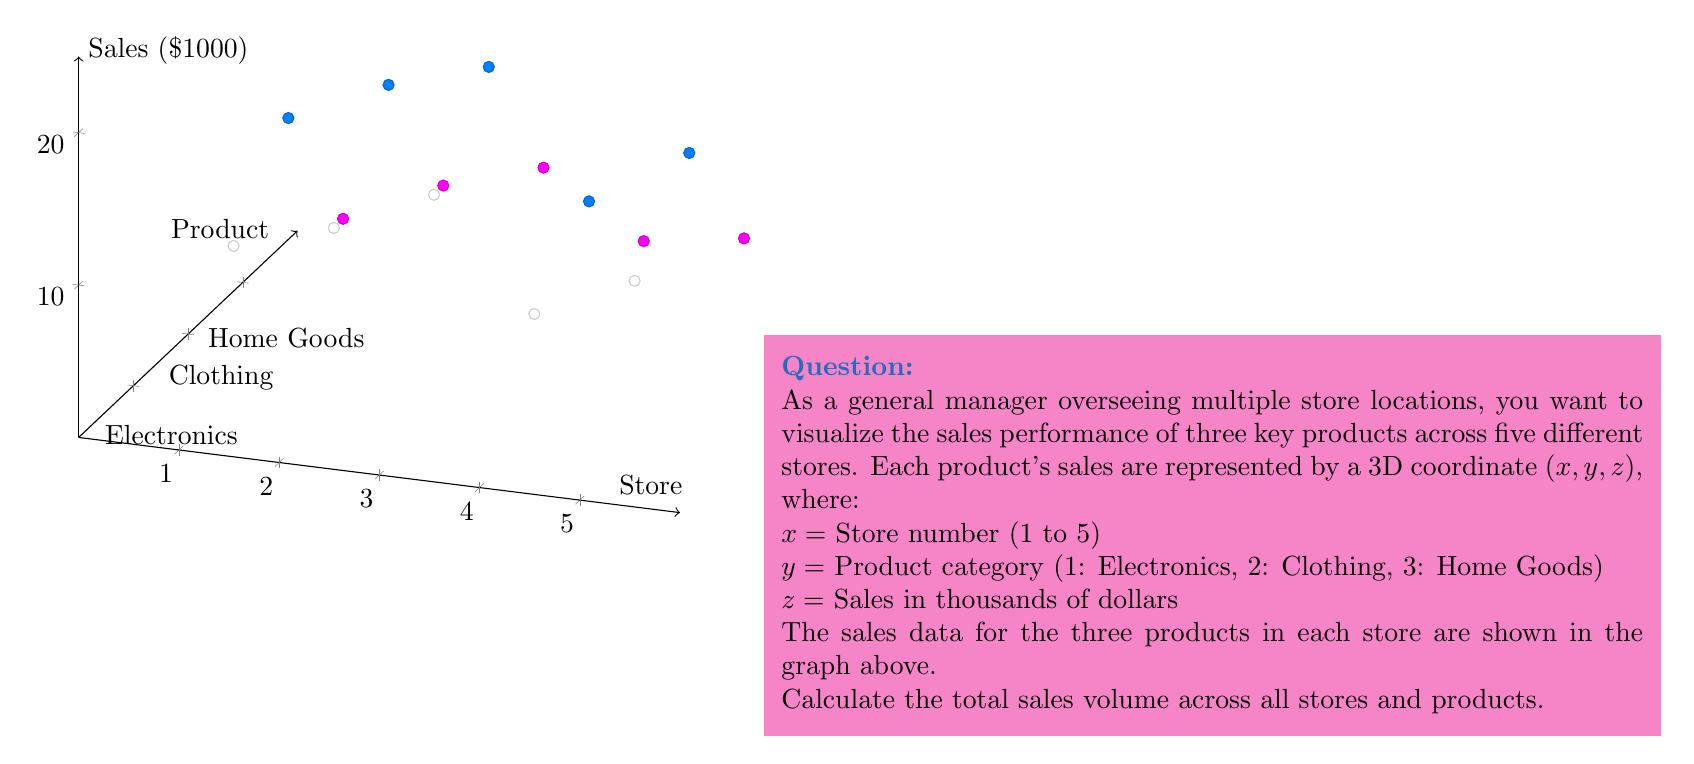What is the answer to this math problem? To solve this problem, we need to sum up the sales (z-coordinate) for all products across all stores. Let's break it down step-by-step:

1) First, let's organize the data into a table:

   Store | Electronics | Clothing | Home Goods
   ------|-------------|----------|-----------
     1   |     10      |    15    |     5
     2   |     12      |    18    |     8
     3   |     15      |    20    |    10
     4   |     8       |    12    |     6
     5   |     11      |    16    |     7

2) Now, we need to sum all these values:

   $$ \text{Total Sales} = \sum_{i=1}^{5}\sum_{j=1}^{3} z_{ij} $$

   Where $i$ represents the store number and $j$ represents the product category.

3) Let's calculate the sum:

   $$ \begin{align*}
   \text{Total Sales} &= (10 + 15 + 5) + (12 + 18 + 8) + (15 + 20 + 10) + (8 + 12 + 6) + (11 + 16 + 7) \\
   &= 30 + 38 + 45 + 26 + 34 \\
   &= 173
   \end{align*} $$

4) Therefore, the total sales volume across all stores and products is 173 thousand dollars.
Answer: $173,000 